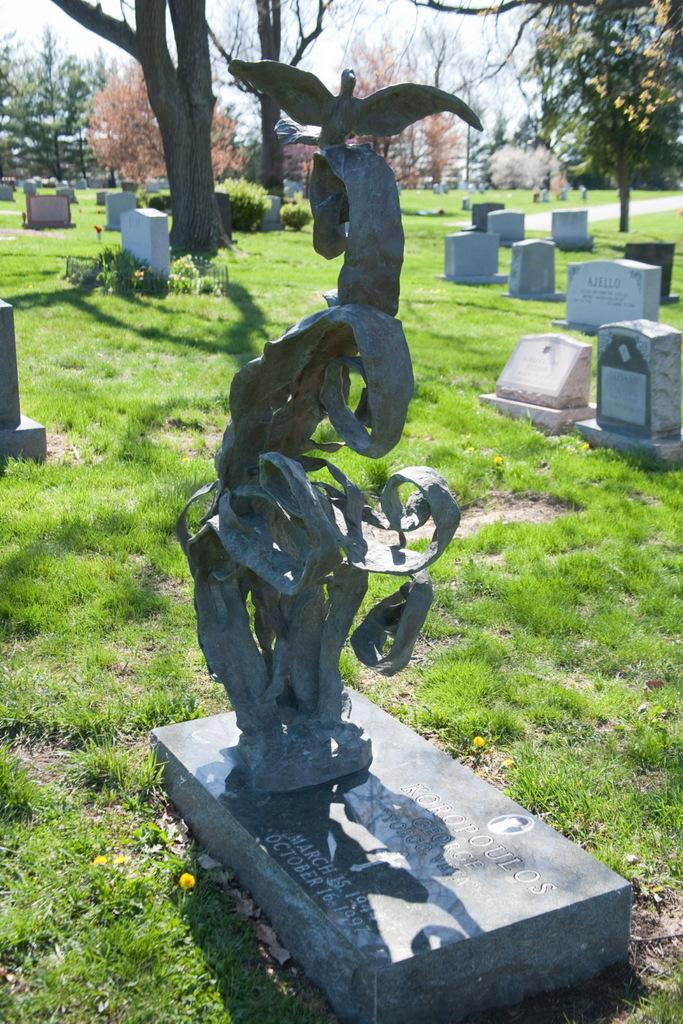What is the main subject in the front middle of the image? There is a cemetery with a statue in the front middle of the image. What can be seen in the background of the image? There is another cemetery in the background of the image. What type of vegetation is present in the background of the image? There are many trees in the background of the image. What is the ground made of in the image? The cemetery and trees are on grass. How is the holiday celebrated in the image? There is no indication of a holiday being celebrated in the image. Is the cemetery a quiet place in the image? The image does not provide information about the noise level or the atmosphere of the cemetery. 